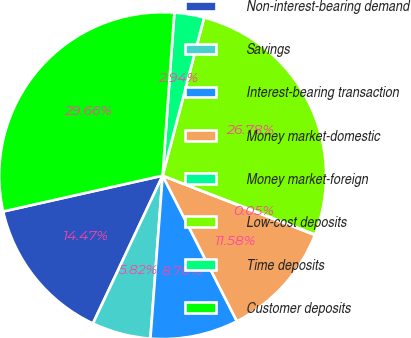Convert chart to OTSL. <chart><loc_0><loc_0><loc_500><loc_500><pie_chart><fcel>Non-interest-bearing demand<fcel>Savings<fcel>Interest-bearing transaction<fcel>Money market-domestic<fcel>Money market-foreign<fcel>Low-cost deposits<fcel>Time deposits<fcel>Customer deposits<nl><fcel>14.47%<fcel>5.82%<fcel>8.7%<fcel>11.58%<fcel>0.05%<fcel>26.78%<fcel>2.94%<fcel>29.66%<nl></chart> 